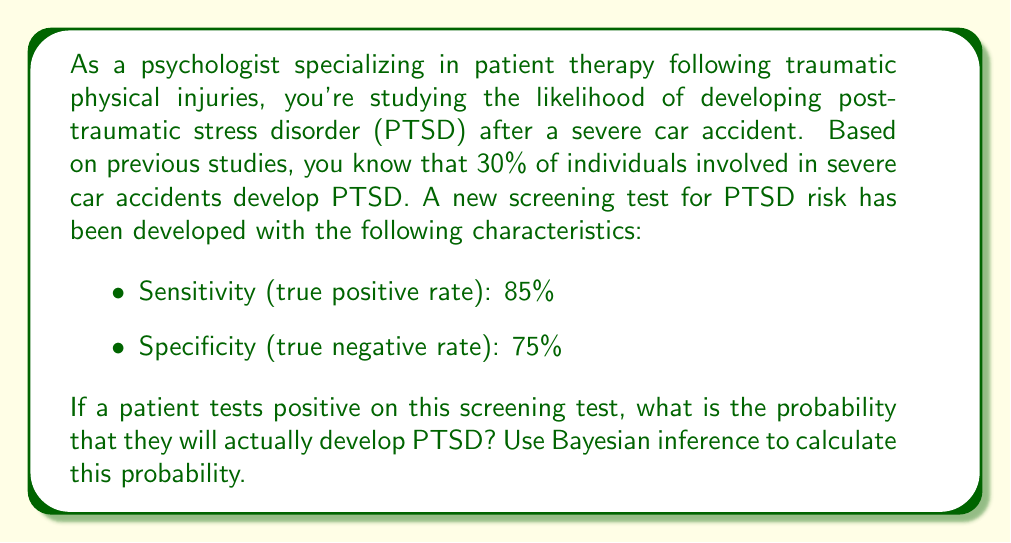Help me with this question. To solve this problem, we'll use Bayes' theorem, which is perfect for updating probabilities based on new evidence. Let's define our events:

A: The patient develops PTSD
B: The patient tests positive on the screening test

We want to find P(A|B), the probability of developing PTSD given a positive test result.

Bayes' theorem states:

$$ P(A|B) = \frac{P(B|A) \cdot P(A)}{P(B)} $$

Given:
- P(A) = 0.30 (prior probability of developing PTSD after a severe car accident)
- P(B|A) = 0.85 (sensitivity of the test)
- P(B|not A) = 1 - 0.75 = 0.25 (false positive rate, complement of specificity)

Step 1: Calculate P(B) using the law of total probability
$$ P(B) = P(B|A) \cdot P(A) + P(B|not A) \cdot P(not A) $$
$$ P(B) = 0.85 \cdot 0.30 + 0.25 \cdot 0.70 = 0.255 + 0.175 = 0.43 $$

Step 2: Apply Bayes' theorem
$$ P(A|B) = \frac{0.85 \cdot 0.30}{0.43} \approx 0.5930 $$

Therefore, the probability that a patient who tests positive will actually develop PTSD is approximately 0.5930 or 59.30%.
Answer: 0.5930 (or 59.30%) 